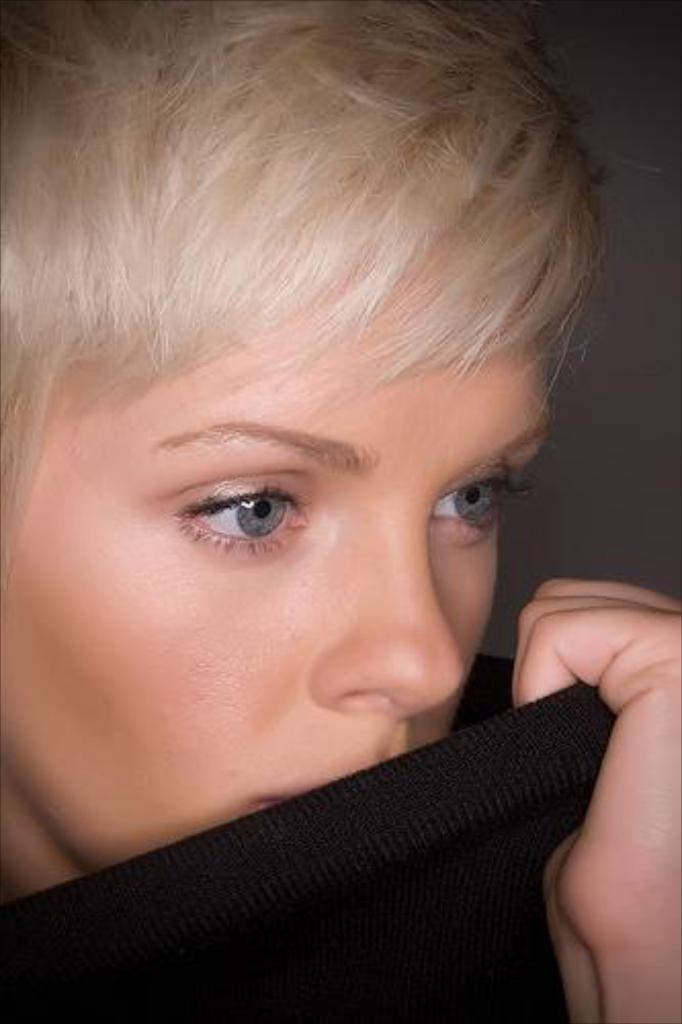In one or two sentences, can you explain what this image depicts? In this image there is a person holding a black color cloth , and there is grey color background. 